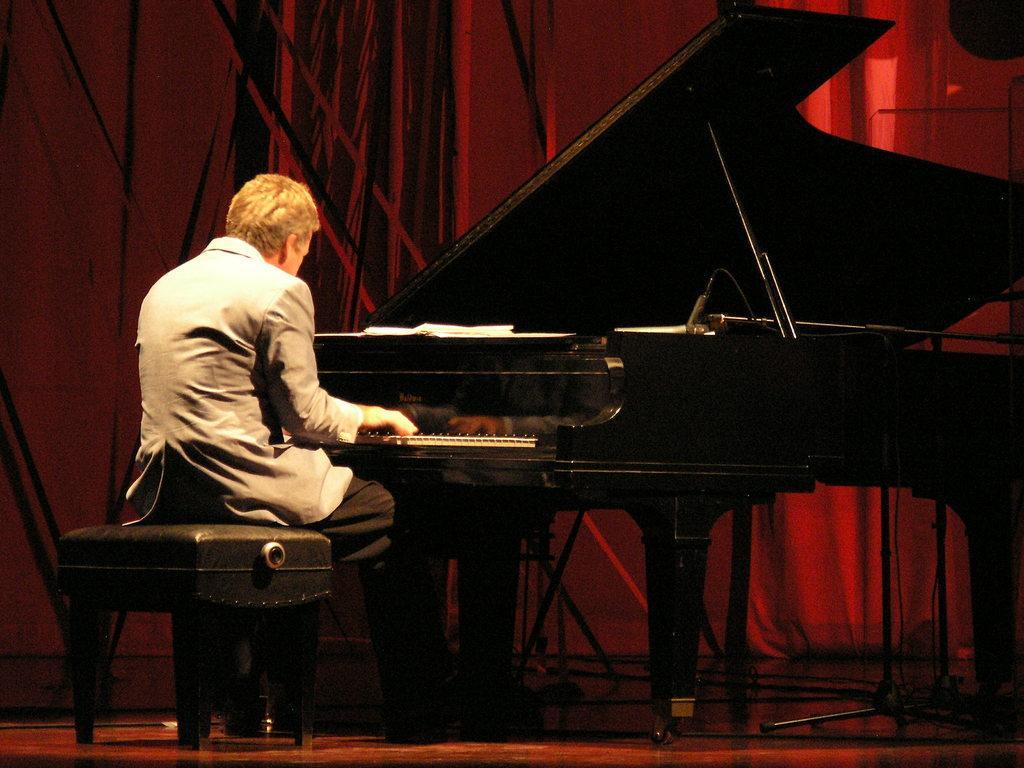Please provide a concise description of this image. This image is taken on the stage. In this image there is a man sitting on a stool and playing a keyboard. In the background there is a curtain. At the bottom of the image there is a stage, a man is wearing a coat which is in grey color. 